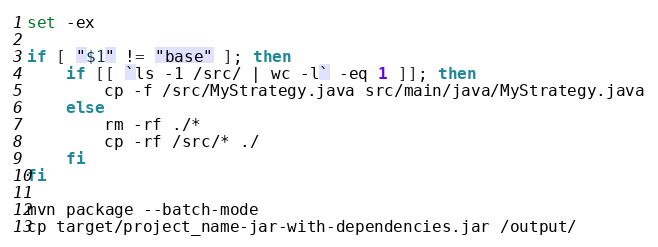Convert code to text. <code><loc_0><loc_0><loc_500><loc_500><_Bash_>set -ex

if [ "$1" != "base" ]; then
    if [[ `ls -1 /src/ | wc -l` -eq 1 ]]; then
        cp -f /src/MyStrategy.java src/main/java/MyStrategy.java
    else
        rm -rf ./*
        cp -rf /src/* ./
    fi
fi

mvn package --batch-mode
cp target/project_name-jar-with-dependencies.jar /output/</code> 